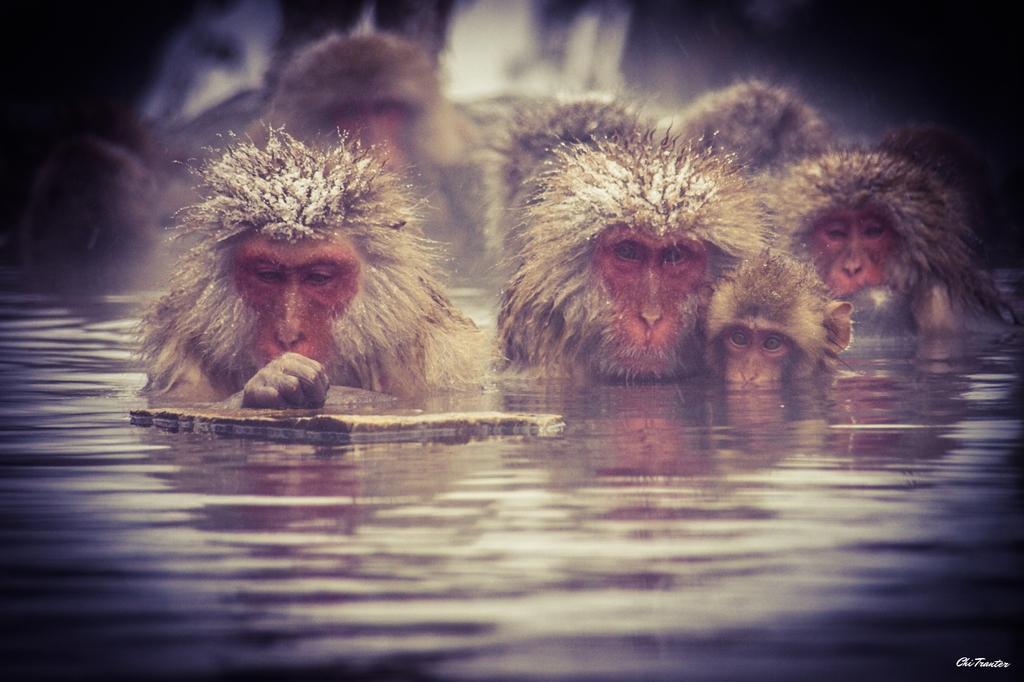Describe this image in one or two sentences. In the center of the image there are monkeys in water. 